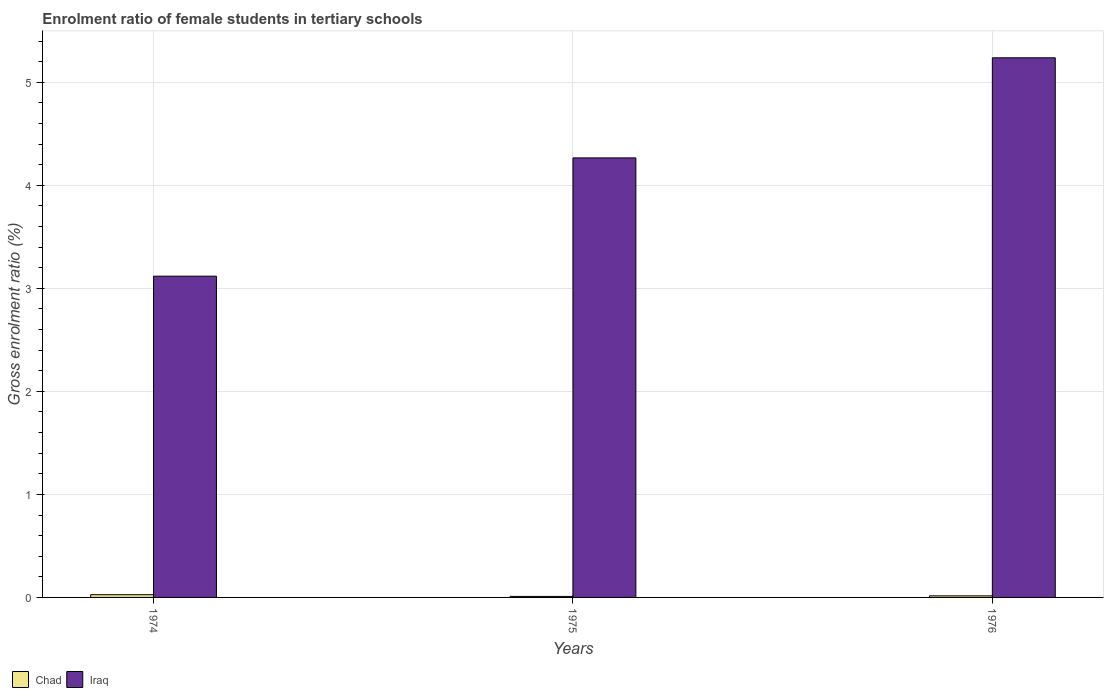How many different coloured bars are there?
Provide a succinct answer. 2. How many bars are there on the 3rd tick from the right?
Give a very brief answer. 2. What is the label of the 1st group of bars from the left?
Your response must be concise. 1974. In how many cases, is the number of bars for a given year not equal to the number of legend labels?
Offer a very short reply. 0. What is the enrolment ratio of female students in tertiary schools in Chad in 1974?
Offer a terse response. 0.03. Across all years, what is the maximum enrolment ratio of female students in tertiary schools in Iraq?
Offer a terse response. 5.24. Across all years, what is the minimum enrolment ratio of female students in tertiary schools in Iraq?
Give a very brief answer. 3.12. In which year was the enrolment ratio of female students in tertiary schools in Iraq maximum?
Make the answer very short. 1976. In which year was the enrolment ratio of female students in tertiary schools in Iraq minimum?
Your answer should be very brief. 1974. What is the total enrolment ratio of female students in tertiary schools in Chad in the graph?
Your response must be concise. 0.05. What is the difference between the enrolment ratio of female students in tertiary schools in Iraq in 1974 and that in 1976?
Your answer should be very brief. -2.12. What is the difference between the enrolment ratio of female students in tertiary schools in Chad in 1975 and the enrolment ratio of female students in tertiary schools in Iraq in 1976?
Keep it short and to the point. -5.23. What is the average enrolment ratio of female students in tertiary schools in Chad per year?
Offer a terse response. 0.02. In the year 1975, what is the difference between the enrolment ratio of female students in tertiary schools in Chad and enrolment ratio of female students in tertiary schools in Iraq?
Offer a very short reply. -4.26. In how many years, is the enrolment ratio of female students in tertiary schools in Iraq greater than 5 %?
Offer a very short reply. 1. What is the ratio of the enrolment ratio of female students in tertiary schools in Iraq in 1975 to that in 1976?
Your response must be concise. 0.81. What is the difference between the highest and the second highest enrolment ratio of female students in tertiary schools in Iraq?
Give a very brief answer. 0.97. What is the difference between the highest and the lowest enrolment ratio of female students in tertiary schools in Iraq?
Provide a succinct answer. 2.12. What does the 1st bar from the left in 1976 represents?
Your answer should be very brief. Chad. What does the 2nd bar from the right in 1976 represents?
Ensure brevity in your answer.  Chad. Are all the bars in the graph horizontal?
Offer a terse response. No. How many years are there in the graph?
Your answer should be very brief. 3. Are the values on the major ticks of Y-axis written in scientific E-notation?
Give a very brief answer. No. Does the graph contain any zero values?
Your answer should be very brief. No. Does the graph contain grids?
Offer a very short reply. Yes. How many legend labels are there?
Make the answer very short. 2. What is the title of the graph?
Keep it short and to the point. Enrolment ratio of female students in tertiary schools. What is the label or title of the Y-axis?
Provide a succinct answer. Gross enrolment ratio (%). What is the Gross enrolment ratio (%) in Chad in 1974?
Your answer should be very brief. 0.03. What is the Gross enrolment ratio (%) in Iraq in 1974?
Provide a short and direct response. 3.12. What is the Gross enrolment ratio (%) in Chad in 1975?
Provide a succinct answer. 0.01. What is the Gross enrolment ratio (%) in Iraq in 1975?
Your answer should be very brief. 4.27. What is the Gross enrolment ratio (%) of Chad in 1976?
Provide a short and direct response. 0.02. What is the Gross enrolment ratio (%) in Iraq in 1976?
Your answer should be compact. 5.24. Across all years, what is the maximum Gross enrolment ratio (%) of Chad?
Provide a succinct answer. 0.03. Across all years, what is the maximum Gross enrolment ratio (%) in Iraq?
Provide a succinct answer. 5.24. Across all years, what is the minimum Gross enrolment ratio (%) in Chad?
Ensure brevity in your answer.  0.01. Across all years, what is the minimum Gross enrolment ratio (%) of Iraq?
Offer a very short reply. 3.12. What is the total Gross enrolment ratio (%) of Chad in the graph?
Provide a succinct answer. 0.05. What is the total Gross enrolment ratio (%) in Iraq in the graph?
Provide a succinct answer. 12.62. What is the difference between the Gross enrolment ratio (%) of Chad in 1974 and that in 1975?
Your answer should be compact. 0.02. What is the difference between the Gross enrolment ratio (%) in Iraq in 1974 and that in 1975?
Offer a very short reply. -1.15. What is the difference between the Gross enrolment ratio (%) in Chad in 1974 and that in 1976?
Make the answer very short. 0.01. What is the difference between the Gross enrolment ratio (%) in Iraq in 1974 and that in 1976?
Your response must be concise. -2.12. What is the difference between the Gross enrolment ratio (%) in Chad in 1975 and that in 1976?
Your response must be concise. -0.01. What is the difference between the Gross enrolment ratio (%) of Iraq in 1975 and that in 1976?
Your answer should be compact. -0.97. What is the difference between the Gross enrolment ratio (%) in Chad in 1974 and the Gross enrolment ratio (%) in Iraq in 1975?
Keep it short and to the point. -4.24. What is the difference between the Gross enrolment ratio (%) of Chad in 1974 and the Gross enrolment ratio (%) of Iraq in 1976?
Provide a short and direct response. -5.21. What is the difference between the Gross enrolment ratio (%) in Chad in 1975 and the Gross enrolment ratio (%) in Iraq in 1976?
Give a very brief answer. -5.23. What is the average Gross enrolment ratio (%) in Chad per year?
Give a very brief answer. 0.02. What is the average Gross enrolment ratio (%) in Iraq per year?
Offer a very short reply. 4.21. In the year 1974, what is the difference between the Gross enrolment ratio (%) of Chad and Gross enrolment ratio (%) of Iraq?
Offer a very short reply. -3.09. In the year 1975, what is the difference between the Gross enrolment ratio (%) in Chad and Gross enrolment ratio (%) in Iraq?
Your response must be concise. -4.26. In the year 1976, what is the difference between the Gross enrolment ratio (%) in Chad and Gross enrolment ratio (%) in Iraq?
Offer a terse response. -5.22. What is the ratio of the Gross enrolment ratio (%) of Chad in 1974 to that in 1975?
Offer a terse response. 2.71. What is the ratio of the Gross enrolment ratio (%) in Iraq in 1974 to that in 1975?
Your answer should be compact. 0.73. What is the ratio of the Gross enrolment ratio (%) of Chad in 1974 to that in 1976?
Your response must be concise. 1.73. What is the ratio of the Gross enrolment ratio (%) of Iraq in 1974 to that in 1976?
Ensure brevity in your answer.  0.6. What is the ratio of the Gross enrolment ratio (%) in Chad in 1975 to that in 1976?
Offer a very short reply. 0.64. What is the ratio of the Gross enrolment ratio (%) in Iraq in 1975 to that in 1976?
Ensure brevity in your answer.  0.81. What is the difference between the highest and the second highest Gross enrolment ratio (%) of Chad?
Make the answer very short. 0.01. What is the difference between the highest and the second highest Gross enrolment ratio (%) of Iraq?
Provide a short and direct response. 0.97. What is the difference between the highest and the lowest Gross enrolment ratio (%) in Chad?
Give a very brief answer. 0.02. What is the difference between the highest and the lowest Gross enrolment ratio (%) of Iraq?
Give a very brief answer. 2.12. 